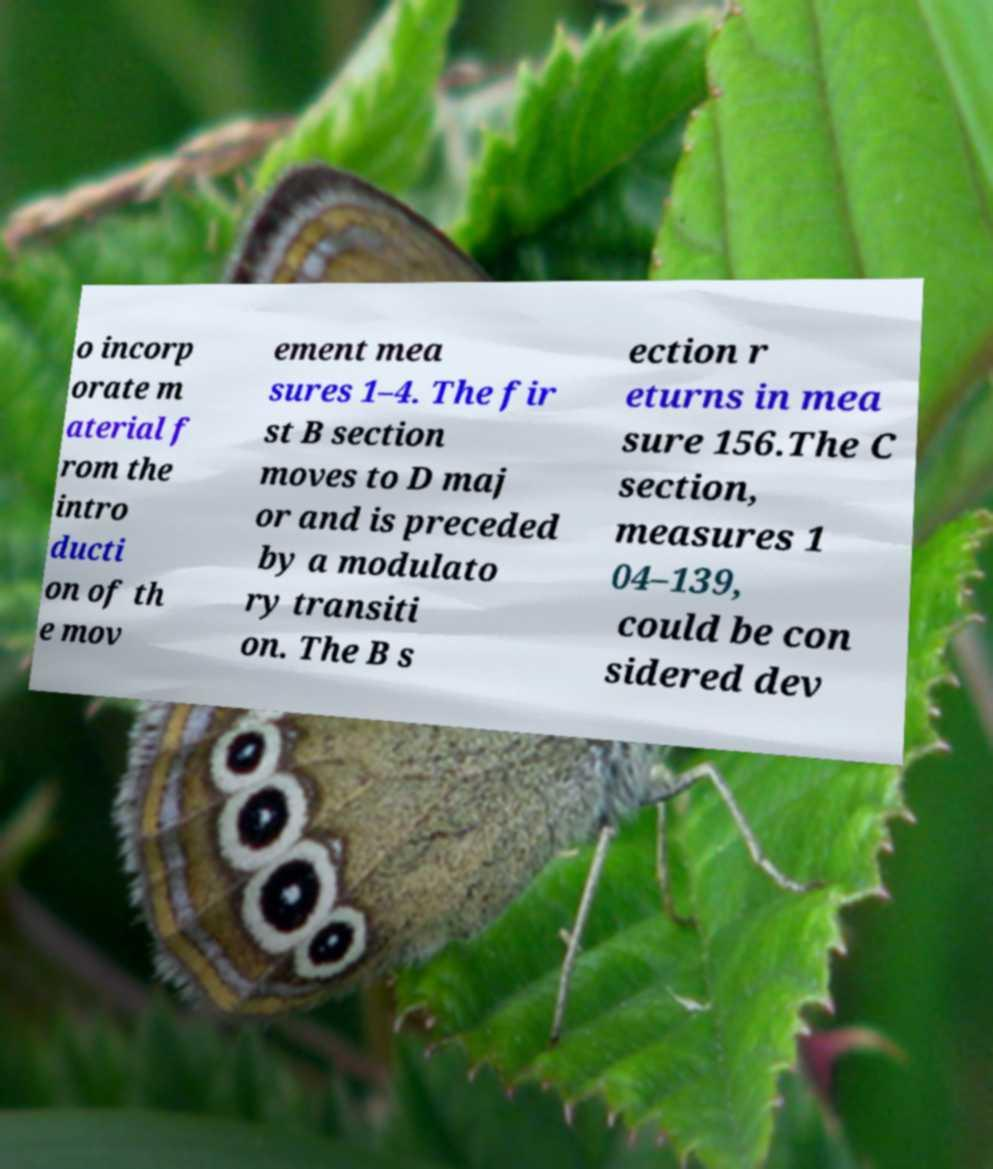For documentation purposes, I need the text within this image transcribed. Could you provide that? o incorp orate m aterial f rom the intro ducti on of th e mov ement mea sures 1–4. The fir st B section moves to D maj or and is preceded by a modulato ry transiti on. The B s ection r eturns in mea sure 156.The C section, measures 1 04–139, could be con sidered dev 